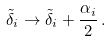Convert formula to latex. <formula><loc_0><loc_0><loc_500><loc_500>\tilde { \delta } _ { i } \rightarrow \tilde { \delta } _ { i } + \frac { \alpha _ { i } } { 2 } \, .</formula> 